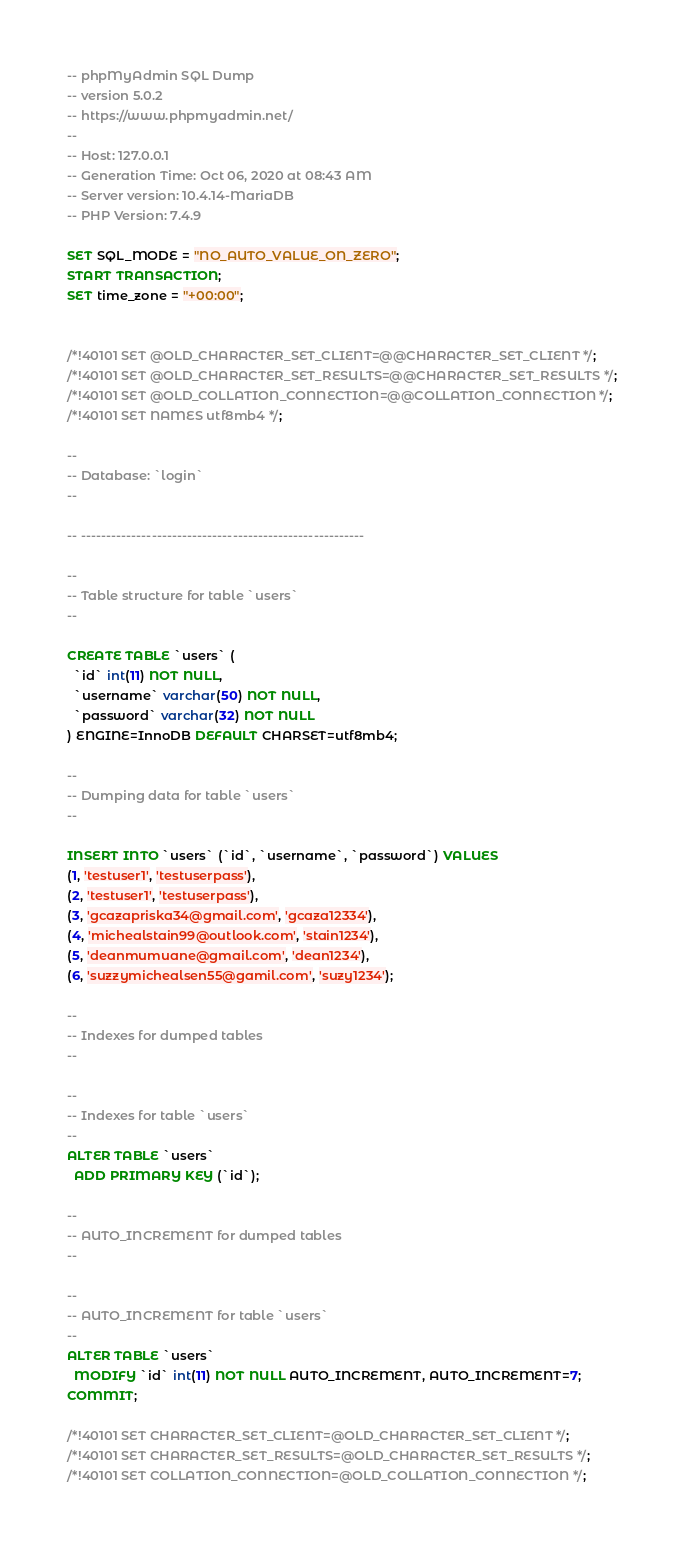Convert code to text. <code><loc_0><loc_0><loc_500><loc_500><_SQL_>-- phpMyAdmin SQL Dump
-- version 5.0.2
-- https://www.phpmyadmin.net/
--
-- Host: 127.0.0.1
-- Generation Time: Oct 06, 2020 at 08:43 AM
-- Server version: 10.4.14-MariaDB
-- PHP Version: 7.4.9

SET SQL_MODE = "NO_AUTO_VALUE_ON_ZERO";
START TRANSACTION;
SET time_zone = "+00:00";


/*!40101 SET @OLD_CHARACTER_SET_CLIENT=@@CHARACTER_SET_CLIENT */;
/*!40101 SET @OLD_CHARACTER_SET_RESULTS=@@CHARACTER_SET_RESULTS */;
/*!40101 SET @OLD_COLLATION_CONNECTION=@@COLLATION_CONNECTION */;
/*!40101 SET NAMES utf8mb4 */;

--
-- Database: `login`
--

-- --------------------------------------------------------

--
-- Table structure for table `users`
--

CREATE TABLE `users` (
  `id` int(11) NOT NULL,
  `username` varchar(50) NOT NULL,
  `password` varchar(32) NOT NULL
) ENGINE=InnoDB DEFAULT CHARSET=utf8mb4;

--
-- Dumping data for table `users`
--

INSERT INTO `users` (`id`, `username`, `password`) VALUES
(1, 'testuser1', 'testuserpass'),
(2, 'testuser1', 'testuserpass'),
(3, 'gcazapriska34@gmail.com', 'gcaza12334'),
(4, 'michealstain99@outlook.com', 'stain1234'),
(5, 'deanmumuane@gmail.com', 'dean1234'),
(6, 'suzzymichealsen55@gamil.com', 'suzy1234');

--
-- Indexes for dumped tables
--

--
-- Indexes for table `users`
--
ALTER TABLE `users`
  ADD PRIMARY KEY (`id`);

--
-- AUTO_INCREMENT for dumped tables
--

--
-- AUTO_INCREMENT for table `users`
--
ALTER TABLE `users`
  MODIFY `id` int(11) NOT NULL AUTO_INCREMENT, AUTO_INCREMENT=7;
COMMIT;

/*!40101 SET CHARACTER_SET_CLIENT=@OLD_CHARACTER_SET_CLIENT */;
/*!40101 SET CHARACTER_SET_RESULTS=@OLD_CHARACTER_SET_RESULTS */;
/*!40101 SET COLLATION_CONNECTION=@OLD_COLLATION_CONNECTION */;
</code> 